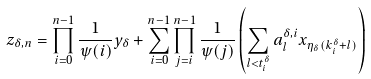<formula> <loc_0><loc_0><loc_500><loc_500>z _ { \delta , n } = \prod _ { i = 0 } ^ { n - 1 } \frac { 1 } { \psi ( i ) } y _ { \delta } + \sum _ { i = 0 } ^ { n - 1 } \prod _ { j = i } ^ { n - 1 } \frac { 1 } { \psi ( j ) } \left ( \sum _ { l < t _ { i } ^ { \delta } } a _ { l } ^ { \delta , i } x _ { \eta _ { \delta } ( k _ { i } ^ { \delta } + l ) } \right )</formula> 